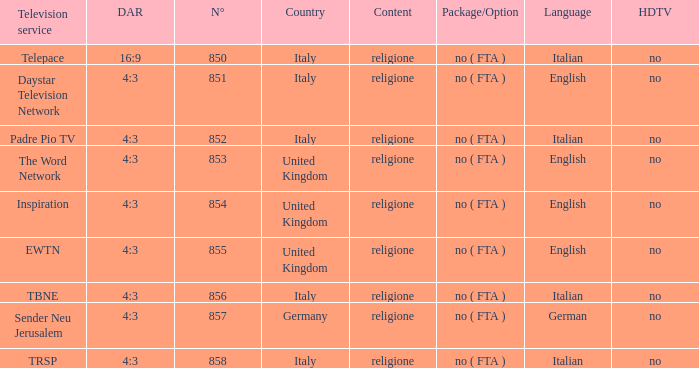How many television service are in italian and n°is greater than 856.0? TRSP. 